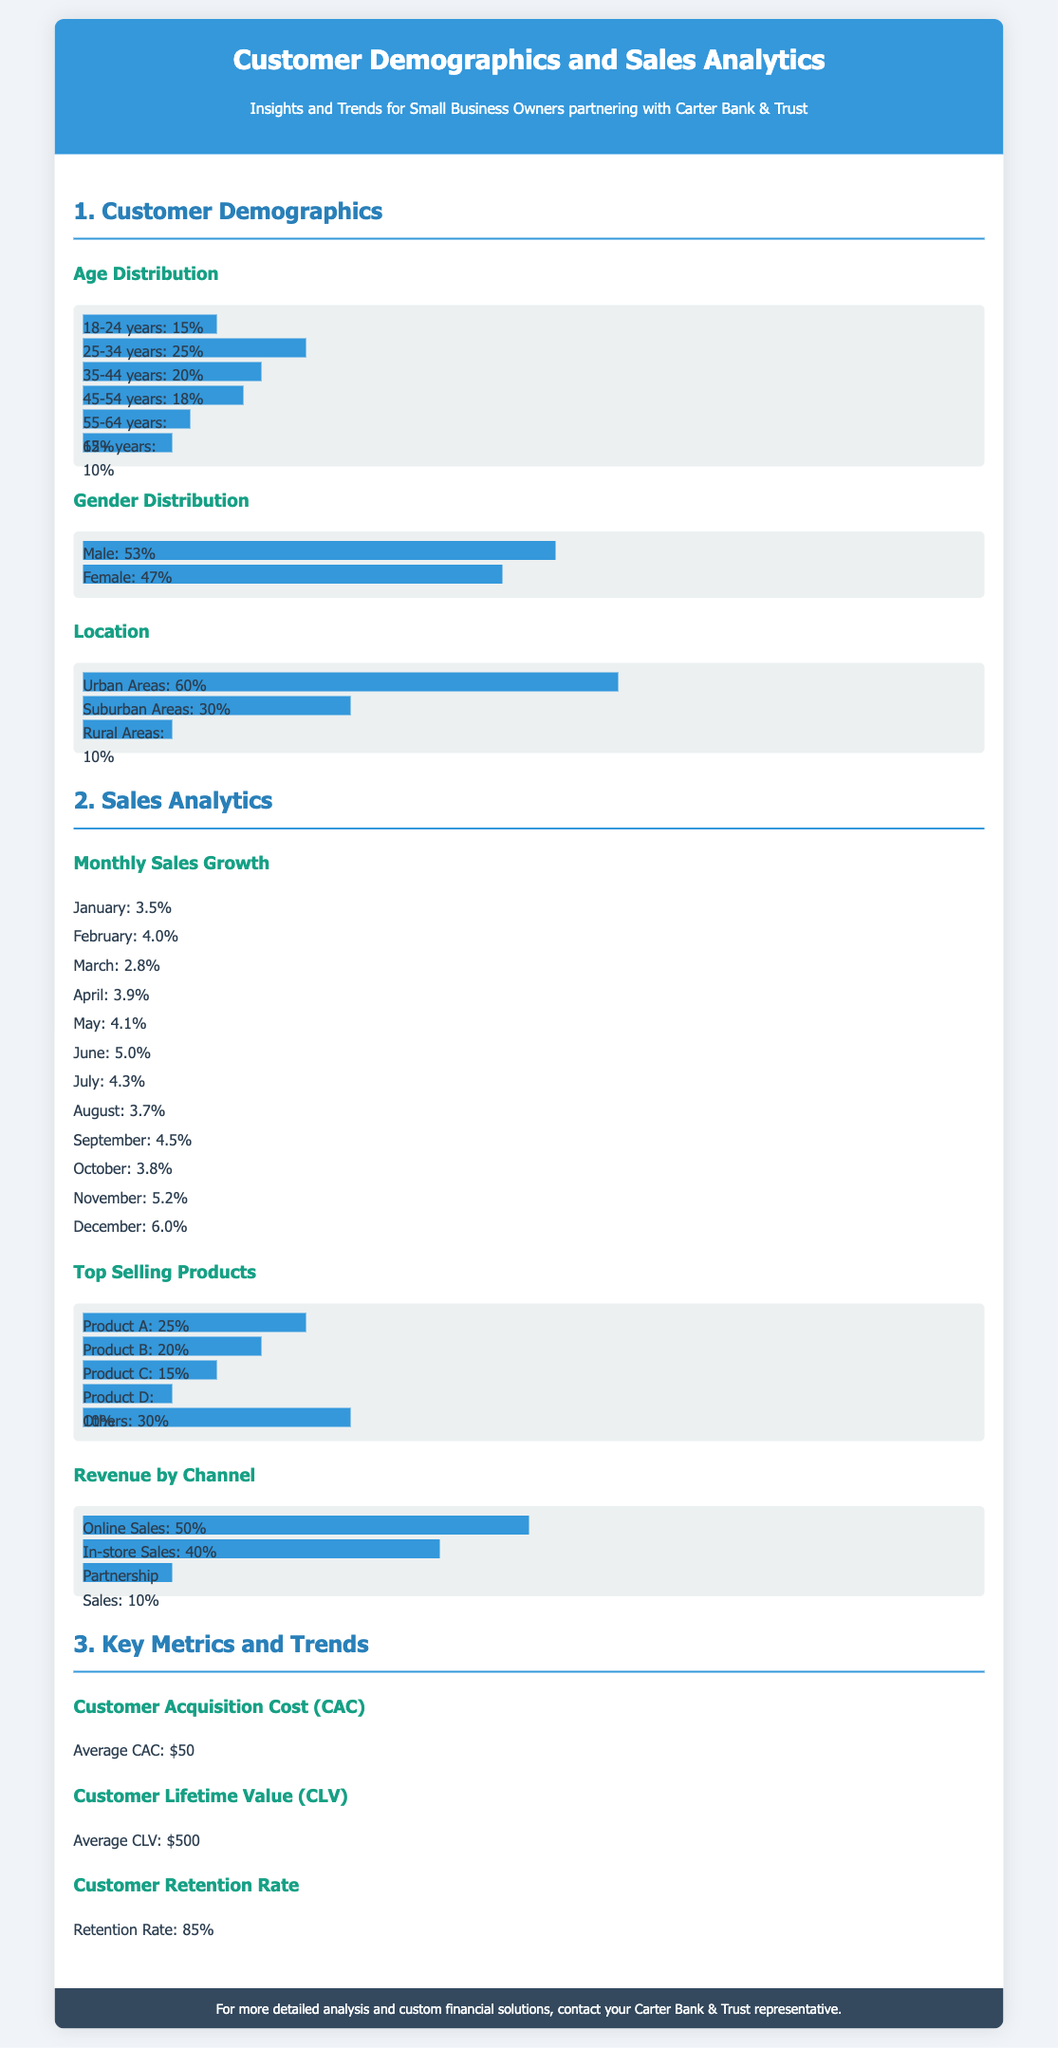What is the percentage of customers aged 25-34? The percentage of customers aged 25-34 is directly listed in the document under Age Distribution.
Answer: 25% What is the average Customer Acquisition Cost (CAC)? The average CAC is stated in the Key Metrics and Trends section of the document.
Answer: $50 What is the percentage growth in sales for November? The percentage growth for November is found in the Monthly Sales Growth section.
Answer: 5.2% What is the gender distribution of customers in terms of percentage for females? The percentage of female customers is provided in the Gender Distribution subsection.
Answer: 47% What is the average Customer Lifetime Value (CLV)? The average CLV is provided in the Key Metrics and Trends section.
Answer: $500 Which product has the highest sales percentage? The product with the highest sales percentage is noted in the Top Selling Products subsection.
Answer: Product A What percentage of revenue comes from Online Sales? The percentage of revenue from Online Sales is indicated in the Revenue by Channel subsection.
Answer: 50% How many percentage points of customers are from rural areas? The percentage of customers from rural areas is directly listed in the Location subsection.
Answer: 10% What is the customer retention rate? The customer retention rate is clearly stated in the Key Metrics and Trends section.
Answer: 85% 